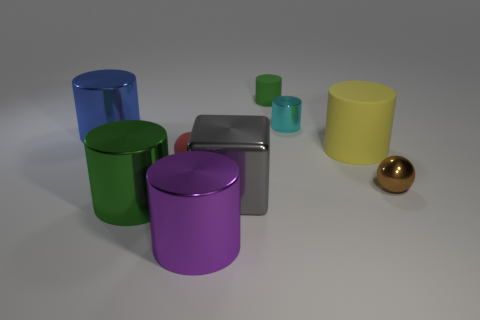Are there any large green metal cylinders?
Provide a succinct answer. Yes. Are there any other things that are the same shape as the blue thing?
Ensure brevity in your answer.  Yes. Are there more cyan things that are in front of the small cyan metal thing than small things?
Keep it short and to the point. No. There is a small green cylinder; are there any yellow objects in front of it?
Provide a succinct answer. Yes. Is the size of the red matte object the same as the gray shiny thing?
Offer a terse response. No. There is a yellow thing that is the same shape as the small green object; what size is it?
Provide a succinct answer. Large. What is the material of the green cylinder behind the large shiny cylinder behind the brown ball?
Your answer should be compact. Rubber. Is the shape of the gray thing the same as the tiny red object?
Provide a short and direct response. No. What number of green cylinders are both in front of the tiny green cylinder and behind the green metal cylinder?
Give a very brief answer. 0. Is the number of green rubber cylinders to the left of the green rubber object the same as the number of cyan metal cylinders that are behind the big blue cylinder?
Make the answer very short. No. 